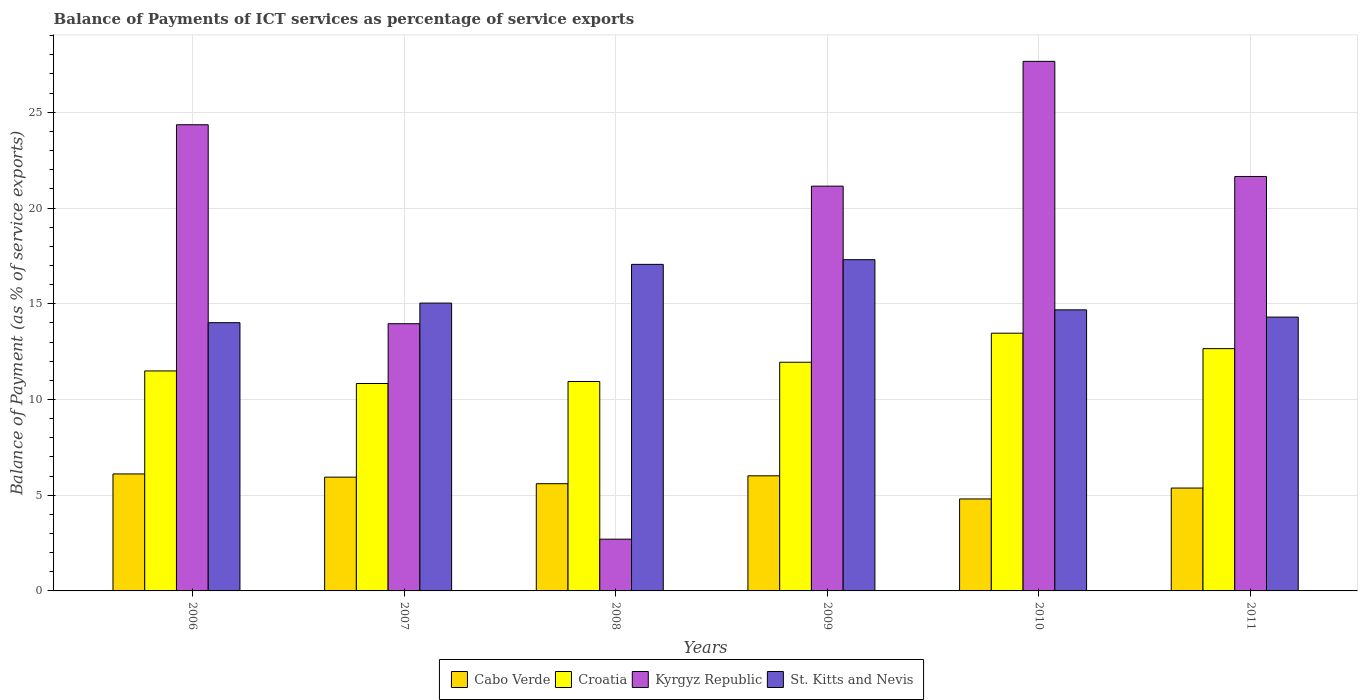How many groups of bars are there?
Ensure brevity in your answer.  6. How many bars are there on the 3rd tick from the left?
Your answer should be compact. 4. In how many cases, is the number of bars for a given year not equal to the number of legend labels?
Offer a very short reply. 0. What is the balance of payments of ICT services in St. Kitts and Nevis in 2006?
Offer a terse response. 14.01. Across all years, what is the maximum balance of payments of ICT services in Kyrgyz Republic?
Keep it short and to the point. 27.66. Across all years, what is the minimum balance of payments of ICT services in Croatia?
Your answer should be compact. 10.83. What is the total balance of payments of ICT services in Cabo Verde in the graph?
Your answer should be very brief. 33.84. What is the difference between the balance of payments of ICT services in Kyrgyz Republic in 2008 and that in 2009?
Provide a succinct answer. -18.44. What is the difference between the balance of payments of ICT services in St. Kitts and Nevis in 2007 and the balance of payments of ICT services in Kyrgyz Republic in 2009?
Provide a succinct answer. -6.11. What is the average balance of payments of ICT services in Cabo Verde per year?
Provide a short and direct response. 5.64. In the year 2010, what is the difference between the balance of payments of ICT services in St. Kitts and Nevis and balance of payments of ICT services in Cabo Verde?
Keep it short and to the point. 9.88. In how many years, is the balance of payments of ICT services in Croatia greater than 9 %?
Your answer should be compact. 6. What is the ratio of the balance of payments of ICT services in Kyrgyz Republic in 2008 to that in 2010?
Offer a very short reply. 0.1. Is the difference between the balance of payments of ICT services in St. Kitts and Nevis in 2006 and 2009 greater than the difference between the balance of payments of ICT services in Cabo Verde in 2006 and 2009?
Give a very brief answer. No. What is the difference between the highest and the second highest balance of payments of ICT services in Croatia?
Ensure brevity in your answer.  0.81. What is the difference between the highest and the lowest balance of payments of ICT services in Cabo Verde?
Provide a short and direct response. 1.31. In how many years, is the balance of payments of ICT services in Croatia greater than the average balance of payments of ICT services in Croatia taken over all years?
Make the answer very short. 3. Is it the case that in every year, the sum of the balance of payments of ICT services in Cabo Verde and balance of payments of ICT services in St. Kitts and Nevis is greater than the sum of balance of payments of ICT services in Croatia and balance of payments of ICT services in Kyrgyz Republic?
Your answer should be very brief. Yes. What does the 4th bar from the left in 2009 represents?
Your response must be concise. St. Kitts and Nevis. What does the 1st bar from the right in 2008 represents?
Your response must be concise. St. Kitts and Nevis. How many bars are there?
Your answer should be compact. 24. What is the difference between two consecutive major ticks on the Y-axis?
Keep it short and to the point. 5. Are the values on the major ticks of Y-axis written in scientific E-notation?
Ensure brevity in your answer.  No. Does the graph contain grids?
Ensure brevity in your answer.  Yes. Where does the legend appear in the graph?
Provide a short and direct response. Bottom center. What is the title of the graph?
Your response must be concise. Balance of Payments of ICT services as percentage of service exports. What is the label or title of the X-axis?
Your response must be concise. Years. What is the label or title of the Y-axis?
Ensure brevity in your answer.  Balance of Payment (as % of service exports). What is the Balance of Payment (as % of service exports) in Cabo Verde in 2006?
Your response must be concise. 6.11. What is the Balance of Payment (as % of service exports) of Croatia in 2006?
Keep it short and to the point. 11.49. What is the Balance of Payment (as % of service exports) in Kyrgyz Republic in 2006?
Keep it short and to the point. 24.35. What is the Balance of Payment (as % of service exports) in St. Kitts and Nevis in 2006?
Your response must be concise. 14.01. What is the Balance of Payment (as % of service exports) in Cabo Verde in 2007?
Provide a succinct answer. 5.94. What is the Balance of Payment (as % of service exports) of Croatia in 2007?
Provide a short and direct response. 10.83. What is the Balance of Payment (as % of service exports) in Kyrgyz Republic in 2007?
Offer a very short reply. 13.96. What is the Balance of Payment (as % of service exports) of St. Kitts and Nevis in 2007?
Provide a short and direct response. 15.03. What is the Balance of Payment (as % of service exports) in Cabo Verde in 2008?
Offer a very short reply. 5.6. What is the Balance of Payment (as % of service exports) of Croatia in 2008?
Offer a very short reply. 10.94. What is the Balance of Payment (as % of service exports) in Kyrgyz Republic in 2008?
Your answer should be very brief. 2.7. What is the Balance of Payment (as % of service exports) in St. Kitts and Nevis in 2008?
Give a very brief answer. 17.06. What is the Balance of Payment (as % of service exports) in Cabo Verde in 2009?
Make the answer very short. 6.01. What is the Balance of Payment (as % of service exports) of Croatia in 2009?
Make the answer very short. 11.94. What is the Balance of Payment (as % of service exports) of Kyrgyz Republic in 2009?
Give a very brief answer. 21.14. What is the Balance of Payment (as % of service exports) of St. Kitts and Nevis in 2009?
Offer a terse response. 17.3. What is the Balance of Payment (as % of service exports) in Cabo Verde in 2010?
Ensure brevity in your answer.  4.8. What is the Balance of Payment (as % of service exports) of Croatia in 2010?
Keep it short and to the point. 13.46. What is the Balance of Payment (as % of service exports) in Kyrgyz Republic in 2010?
Provide a succinct answer. 27.66. What is the Balance of Payment (as % of service exports) of St. Kitts and Nevis in 2010?
Provide a succinct answer. 14.68. What is the Balance of Payment (as % of service exports) of Cabo Verde in 2011?
Ensure brevity in your answer.  5.37. What is the Balance of Payment (as % of service exports) in Croatia in 2011?
Make the answer very short. 12.66. What is the Balance of Payment (as % of service exports) in Kyrgyz Republic in 2011?
Provide a succinct answer. 21.65. What is the Balance of Payment (as % of service exports) of St. Kitts and Nevis in 2011?
Ensure brevity in your answer.  14.3. Across all years, what is the maximum Balance of Payment (as % of service exports) in Cabo Verde?
Your response must be concise. 6.11. Across all years, what is the maximum Balance of Payment (as % of service exports) in Croatia?
Your response must be concise. 13.46. Across all years, what is the maximum Balance of Payment (as % of service exports) in Kyrgyz Republic?
Make the answer very short. 27.66. Across all years, what is the maximum Balance of Payment (as % of service exports) in St. Kitts and Nevis?
Provide a succinct answer. 17.3. Across all years, what is the minimum Balance of Payment (as % of service exports) in Cabo Verde?
Make the answer very short. 4.8. Across all years, what is the minimum Balance of Payment (as % of service exports) of Croatia?
Keep it short and to the point. 10.83. Across all years, what is the minimum Balance of Payment (as % of service exports) of Kyrgyz Republic?
Keep it short and to the point. 2.7. Across all years, what is the minimum Balance of Payment (as % of service exports) of St. Kitts and Nevis?
Give a very brief answer. 14.01. What is the total Balance of Payment (as % of service exports) of Cabo Verde in the graph?
Your answer should be very brief. 33.84. What is the total Balance of Payment (as % of service exports) of Croatia in the graph?
Keep it short and to the point. 71.32. What is the total Balance of Payment (as % of service exports) in Kyrgyz Republic in the graph?
Keep it short and to the point. 111.46. What is the total Balance of Payment (as % of service exports) in St. Kitts and Nevis in the graph?
Ensure brevity in your answer.  92.39. What is the difference between the Balance of Payment (as % of service exports) of Cabo Verde in 2006 and that in 2007?
Provide a short and direct response. 0.17. What is the difference between the Balance of Payment (as % of service exports) of Croatia in 2006 and that in 2007?
Provide a short and direct response. 0.66. What is the difference between the Balance of Payment (as % of service exports) in Kyrgyz Republic in 2006 and that in 2007?
Give a very brief answer. 10.39. What is the difference between the Balance of Payment (as % of service exports) in St. Kitts and Nevis in 2006 and that in 2007?
Offer a very short reply. -1.02. What is the difference between the Balance of Payment (as % of service exports) of Cabo Verde in 2006 and that in 2008?
Your answer should be very brief. 0.51. What is the difference between the Balance of Payment (as % of service exports) of Croatia in 2006 and that in 2008?
Offer a terse response. 0.55. What is the difference between the Balance of Payment (as % of service exports) of Kyrgyz Republic in 2006 and that in 2008?
Offer a very short reply. 21.65. What is the difference between the Balance of Payment (as % of service exports) of St. Kitts and Nevis in 2006 and that in 2008?
Provide a succinct answer. -3.05. What is the difference between the Balance of Payment (as % of service exports) of Cabo Verde in 2006 and that in 2009?
Provide a short and direct response. 0.1. What is the difference between the Balance of Payment (as % of service exports) in Croatia in 2006 and that in 2009?
Ensure brevity in your answer.  -0.45. What is the difference between the Balance of Payment (as % of service exports) in Kyrgyz Republic in 2006 and that in 2009?
Keep it short and to the point. 3.21. What is the difference between the Balance of Payment (as % of service exports) of St. Kitts and Nevis in 2006 and that in 2009?
Your answer should be compact. -3.29. What is the difference between the Balance of Payment (as % of service exports) of Cabo Verde in 2006 and that in 2010?
Offer a very short reply. 1.31. What is the difference between the Balance of Payment (as % of service exports) of Croatia in 2006 and that in 2010?
Make the answer very short. -1.97. What is the difference between the Balance of Payment (as % of service exports) of Kyrgyz Republic in 2006 and that in 2010?
Your answer should be compact. -3.31. What is the difference between the Balance of Payment (as % of service exports) of St. Kitts and Nevis in 2006 and that in 2010?
Your response must be concise. -0.67. What is the difference between the Balance of Payment (as % of service exports) in Cabo Verde in 2006 and that in 2011?
Your answer should be very brief. 0.74. What is the difference between the Balance of Payment (as % of service exports) in Croatia in 2006 and that in 2011?
Your answer should be very brief. -1.16. What is the difference between the Balance of Payment (as % of service exports) of Kyrgyz Republic in 2006 and that in 2011?
Provide a short and direct response. 2.7. What is the difference between the Balance of Payment (as % of service exports) of St. Kitts and Nevis in 2006 and that in 2011?
Ensure brevity in your answer.  -0.29. What is the difference between the Balance of Payment (as % of service exports) in Cabo Verde in 2007 and that in 2008?
Offer a terse response. 0.34. What is the difference between the Balance of Payment (as % of service exports) in Croatia in 2007 and that in 2008?
Give a very brief answer. -0.1. What is the difference between the Balance of Payment (as % of service exports) of Kyrgyz Republic in 2007 and that in 2008?
Offer a very short reply. 11.25. What is the difference between the Balance of Payment (as % of service exports) in St. Kitts and Nevis in 2007 and that in 2008?
Your answer should be compact. -2.02. What is the difference between the Balance of Payment (as % of service exports) of Cabo Verde in 2007 and that in 2009?
Your response must be concise. -0.07. What is the difference between the Balance of Payment (as % of service exports) in Croatia in 2007 and that in 2009?
Provide a succinct answer. -1.11. What is the difference between the Balance of Payment (as % of service exports) of Kyrgyz Republic in 2007 and that in 2009?
Make the answer very short. -7.19. What is the difference between the Balance of Payment (as % of service exports) in St. Kitts and Nevis in 2007 and that in 2009?
Keep it short and to the point. -2.27. What is the difference between the Balance of Payment (as % of service exports) in Cabo Verde in 2007 and that in 2010?
Offer a terse response. 1.14. What is the difference between the Balance of Payment (as % of service exports) of Croatia in 2007 and that in 2010?
Keep it short and to the point. -2.63. What is the difference between the Balance of Payment (as % of service exports) in Kyrgyz Republic in 2007 and that in 2010?
Give a very brief answer. -13.7. What is the difference between the Balance of Payment (as % of service exports) in St. Kitts and Nevis in 2007 and that in 2010?
Your answer should be compact. 0.35. What is the difference between the Balance of Payment (as % of service exports) in Cabo Verde in 2007 and that in 2011?
Your response must be concise. 0.57. What is the difference between the Balance of Payment (as % of service exports) in Croatia in 2007 and that in 2011?
Your response must be concise. -1.82. What is the difference between the Balance of Payment (as % of service exports) in Kyrgyz Republic in 2007 and that in 2011?
Offer a terse response. -7.69. What is the difference between the Balance of Payment (as % of service exports) of St. Kitts and Nevis in 2007 and that in 2011?
Ensure brevity in your answer.  0.73. What is the difference between the Balance of Payment (as % of service exports) of Cabo Verde in 2008 and that in 2009?
Provide a succinct answer. -0.41. What is the difference between the Balance of Payment (as % of service exports) in Croatia in 2008 and that in 2009?
Keep it short and to the point. -1.01. What is the difference between the Balance of Payment (as % of service exports) of Kyrgyz Republic in 2008 and that in 2009?
Provide a short and direct response. -18.44. What is the difference between the Balance of Payment (as % of service exports) of St. Kitts and Nevis in 2008 and that in 2009?
Offer a terse response. -0.24. What is the difference between the Balance of Payment (as % of service exports) in Cabo Verde in 2008 and that in 2010?
Provide a succinct answer. 0.8. What is the difference between the Balance of Payment (as % of service exports) of Croatia in 2008 and that in 2010?
Your answer should be compact. -2.52. What is the difference between the Balance of Payment (as % of service exports) in Kyrgyz Republic in 2008 and that in 2010?
Your answer should be compact. -24.96. What is the difference between the Balance of Payment (as % of service exports) of St. Kitts and Nevis in 2008 and that in 2010?
Your answer should be compact. 2.38. What is the difference between the Balance of Payment (as % of service exports) of Cabo Verde in 2008 and that in 2011?
Your answer should be compact. 0.23. What is the difference between the Balance of Payment (as % of service exports) of Croatia in 2008 and that in 2011?
Your answer should be compact. -1.72. What is the difference between the Balance of Payment (as % of service exports) in Kyrgyz Republic in 2008 and that in 2011?
Your answer should be compact. -18.94. What is the difference between the Balance of Payment (as % of service exports) in St. Kitts and Nevis in 2008 and that in 2011?
Your response must be concise. 2.75. What is the difference between the Balance of Payment (as % of service exports) in Cabo Verde in 2009 and that in 2010?
Your response must be concise. 1.21. What is the difference between the Balance of Payment (as % of service exports) in Croatia in 2009 and that in 2010?
Provide a succinct answer. -1.52. What is the difference between the Balance of Payment (as % of service exports) in Kyrgyz Republic in 2009 and that in 2010?
Make the answer very short. -6.52. What is the difference between the Balance of Payment (as % of service exports) of St. Kitts and Nevis in 2009 and that in 2010?
Make the answer very short. 2.62. What is the difference between the Balance of Payment (as % of service exports) of Cabo Verde in 2009 and that in 2011?
Make the answer very short. 0.64. What is the difference between the Balance of Payment (as % of service exports) in Croatia in 2009 and that in 2011?
Offer a terse response. -0.71. What is the difference between the Balance of Payment (as % of service exports) of Kyrgyz Republic in 2009 and that in 2011?
Your answer should be compact. -0.5. What is the difference between the Balance of Payment (as % of service exports) in St. Kitts and Nevis in 2009 and that in 2011?
Give a very brief answer. 3. What is the difference between the Balance of Payment (as % of service exports) of Cabo Verde in 2010 and that in 2011?
Offer a terse response. -0.57. What is the difference between the Balance of Payment (as % of service exports) in Croatia in 2010 and that in 2011?
Provide a short and direct response. 0.81. What is the difference between the Balance of Payment (as % of service exports) of Kyrgyz Republic in 2010 and that in 2011?
Offer a terse response. 6.01. What is the difference between the Balance of Payment (as % of service exports) in St. Kitts and Nevis in 2010 and that in 2011?
Your answer should be compact. 0.38. What is the difference between the Balance of Payment (as % of service exports) of Cabo Verde in 2006 and the Balance of Payment (as % of service exports) of Croatia in 2007?
Provide a short and direct response. -4.72. What is the difference between the Balance of Payment (as % of service exports) in Cabo Verde in 2006 and the Balance of Payment (as % of service exports) in Kyrgyz Republic in 2007?
Keep it short and to the point. -7.85. What is the difference between the Balance of Payment (as % of service exports) of Cabo Verde in 2006 and the Balance of Payment (as % of service exports) of St. Kitts and Nevis in 2007?
Give a very brief answer. -8.92. What is the difference between the Balance of Payment (as % of service exports) of Croatia in 2006 and the Balance of Payment (as % of service exports) of Kyrgyz Republic in 2007?
Ensure brevity in your answer.  -2.47. What is the difference between the Balance of Payment (as % of service exports) in Croatia in 2006 and the Balance of Payment (as % of service exports) in St. Kitts and Nevis in 2007?
Your answer should be compact. -3.54. What is the difference between the Balance of Payment (as % of service exports) of Kyrgyz Republic in 2006 and the Balance of Payment (as % of service exports) of St. Kitts and Nevis in 2007?
Your answer should be very brief. 9.31. What is the difference between the Balance of Payment (as % of service exports) of Cabo Verde in 2006 and the Balance of Payment (as % of service exports) of Croatia in 2008?
Your answer should be compact. -4.83. What is the difference between the Balance of Payment (as % of service exports) of Cabo Verde in 2006 and the Balance of Payment (as % of service exports) of Kyrgyz Republic in 2008?
Provide a succinct answer. 3.41. What is the difference between the Balance of Payment (as % of service exports) of Cabo Verde in 2006 and the Balance of Payment (as % of service exports) of St. Kitts and Nevis in 2008?
Your answer should be very brief. -10.95. What is the difference between the Balance of Payment (as % of service exports) of Croatia in 2006 and the Balance of Payment (as % of service exports) of Kyrgyz Republic in 2008?
Give a very brief answer. 8.79. What is the difference between the Balance of Payment (as % of service exports) in Croatia in 2006 and the Balance of Payment (as % of service exports) in St. Kitts and Nevis in 2008?
Keep it short and to the point. -5.57. What is the difference between the Balance of Payment (as % of service exports) in Kyrgyz Republic in 2006 and the Balance of Payment (as % of service exports) in St. Kitts and Nevis in 2008?
Your answer should be very brief. 7.29. What is the difference between the Balance of Payment (as % of service exports) of Cabo Verde in 2006 and the Balance of Payment (as % of service exports) of Croatia in 2009?
Provide a succinct answer. -5.83. What is the difference between the Balance of Payment (as % of service exports) in Cabo Verde in 2006 and the Balance of Payment (as % of service exports) in Kyrgyz Republic in 2009?
Your answer should be very brief. -15.03. What is the difference between the Balance of Payment (as % of service exports) in Cabo Verde in 2006 and the Balance of Payment (as % of service exports) in St. Kitts and Nevis in 2009?
Offer a very short reply. -11.19. What is the difference between the Balance of Payment (as % of service exports) in Croatia in 2006 and the Balance of Payment (as % of service exports) in Kyrgyz Republic in 2009?
Give a very brief answer. -9.65. What is the difference between the Balance of Payment (as % of service exports) of Croatia in 2006 and the Balance of Payment (as % of service exports) of St. Kitts and Nevis in 2009?
Offer a very short reply. -5.81. What is the difference between the Balance of Payment (as % of service exports) in Kyrgyz Republic in 2006 and the Balance of Payment (as % of service exports) in St. Kitts and Nevis in 2009?
Ensure brevity in your answer.  7.05. What is the difference between the Balance of Payment (as % of service exports) of Cabo Verde in 2006 and the Balance of Payment (as % of service exports) of Croatia in 2010?
Your answer should be compact. -7.35. What is the difference between the Balance of Payment (as % of service exports) in Cabo Verde in 2006 and the Balance of Payment (as % of service exports) in Kyrgyz Republic in 2010?
Offer a very short reply. -21.55. What is the difference between the Balance of Payment (as % of service exports) of Cabo Verde in 2006 and the Balance of Payment (as % of service exports) of St. Kitts and Nevis in 2010?
Ensure brevity in your answer.  -8.57. What is the difference between the Balance of Payment (as % of service exports) in Croatia in 2006 and the Balance of Payment (as % of service exports) in Kyrgyz Republic in 2010?
Make the answer very short. -16.17. What is the difference between the Balance of Payment (as % of service exports) of Croatia in 2006 and the Balance of Payment (as % of service exports) of St. Kitts and Nevis in 2010?
Give a very brief answer. -3.19. What is the difference between the Balance of Payment (as % of service exports) in Kyrgyz Republic in 2006 and the Balance of Payment (as % of service exports) in St. Kitts and Nevis in 2010?
Keep it short and to the point. 9.67. What is the difference between the Balance of Payment (as % of service exports) in Cabo Verde in 2006 and the Balance of Payment (as % of service exports) in Croatia in 2011?
Ensure brevity in your answer.  -6.54. What is the difference between the Balance of Payment (as % of service exports) of Cabo Verde in 2006 and the Balance of Payment (as % of service exports) of Kyrgyz Republic in 2011?
Make the answer very short. -15.54. What is the difference between the Balance of Payment (as % of service exports) in Cabo Verde in 2006 and the Balance of Payment (as % of service exports) in St. Kitts and Nevis in 2011?
Your answer should be compact. -8.19. What is the difference between the Balance of Payment (as % of service exports) in Croatia in 2006 and the Balance of Payment (as % of service exports) in Kyrgyz Republic in 2011?
Make the answer very short. -10.16. What is the difference between the Balance of Payment (as % of service exports) in Croatia in 2006 and the Balance of Payment (as % of service exports) in St. Kitts and Nevis in 2011?
Your response must be concise. -2.81. What is the difference between the Balance of Payment (as % of service exports) in Kyrgyz Republic in 2006 and the Balance of Payment (as % of service exports) in St. Kitts and Nevis in 2011?
Your response must be concise. 10.05. What is the difference between the Balance of Payment (as % of service exports) in Cabo Verde in 2007 and the Balance of Payment (as % of service exports) in Croatia in 2008?
Keep it short and to the point. -5. What is the difference between the Balance of Payment (as % of service exports) of Cabo Verde in 2007 and the Balance of Payment (as % of service exports) of Kyrgyz Republic in 2008?
Keep it short and to the point. 3.24. What is the difference between the Balance of Payment (as % of service exports) of Cabo Verde in 2007 and the Balance of Payment (as % of service exports) of St. Kitts and Nevis in 2008?
Your response must be concise. -11.11. What is the difference between the Balance of Payment (as % of service exports) in Croatia in 2007 and the Balance of Payment (as % of service exports) in Kyrgyz Republic in 2008?
Offer a very short reply. 8.13. What is the difference between the Balance of Payment (as % of service exports) in Croatia in 2007 and the Balance of Payment (as % of service exports) in St. Kitts and Nevis in 2008?
Your response must be concise. -6.22. What is the difference between the Balance of Payment (as % of service exports) in Kyrgyz Republic in 2007 and the Balance of Payment (as % of service exports) in St. Kitts and Nevis in 2008?
Give a very brief answer. -3.1. What is the difference between the Balance of Payment (as % of service exports) in Cabo Verde in 2007 and the Balance of Payment (as % of service exports) in Croatia in 2009?
Provide a short and direct response. -6. What is the difference between the Balance of Payment (as % of service exports) in Cabo Verde in 2007 and the Balance of Payment (as % of service exports) in Kyrgyz Republic in 2009?
Provide a succinct answer. -15.2. What is the difference between the Balance of Payment (as % of service exports) of Cabo Verde in 2007 and the Balance of Payment (as % of service exports) of St. Kitts and Nevis in 2009?
Make the answer very short. -11.36. What is the difference between the Balance of Payment (as % of service exports) of Croatia in 2007 and the Balance of Payment (as % of service exports) of Kyrgyz Republic in 2009?
Your answer should be compact. -10.31. What is the difference between the Balance of Payment (as % of service exports) in Croatia in 2007 and the Balance of Payment (as % of service exports) in St. Kitts and Nevis in 2009?
Offer a terse response. -6.47. What is the difference between the Balance of Payment (as % of service exports) in Kyrgyz Republic in 2007 and the Balance of Payment (as % of service exports) in St. Kitts and Nevis in 2009?
Your answer should be compact. -3.34. What is the difference between the Balance of Payment (as % of service exports) of Cabo Verde in 2007 and the Balance of Payment (as % of service exports) of Croatia in 2010?
Your answer should be very brief. -7.52. What is the difference between the Balance of Payment (as % of service exports) in Cabo Verde in 2007 and the Balance of Payment (as % of service exports) in Kyrgyz Republic in 2010?
Make the answer very short. -21.72. What is the difference between the Balance of Payment (as % of service exports) in Cabo Verde in 2007 and the Balance of Payment (as % of service exports) in St. Kitts and Nevis in 2010?
Provide a short and direct response. -8.74. What is the difference between the Balance of Payment (as % of service exports) of Croatia in 2007 and the Balance of Payment (as % of service exports) of Kyrgyz Republic in 2010?
Make the answer very short. -16.83. What is the difference between the Balance of Payment (as % of service exports) of Croatia in 2007 and the Balance of Payment (as % of service exports) of St. Kitts and Nevis in 2010?
Your answer should be very brief. -3.85. What is the difference between the Balance of Payment (as % of service exports) in Kyrgyz Republic in 2007 and the Balance of Payment (as % of service exports) in St. Kitts and Nevis in 2010?
Your answer should be very brief. -0.72. What is the difference between the Balance of Payment (as % of service exports) of Cabo Verde in 2007 and the Balance of Payment (as % of service exports) of Croatia in 2011?
Keep it short and to the point. -6.71. What is the difference between the Balance of Payment (as % of service exports) of Cabo Verde in 2007 and the Balance of Payment (as % of service exports) of Kyrgyz Republic in 2011?
Your response must be concise. -15.7. What is the difference between the Balance of Payment (as % of service exports) in Cabo Verde in 2007 and the Balance of Payment (as % of service exports) in St. Kitts and Nevis in 2011?
Ensure brevity in your answer.  -8.36. What is the difference between the Balance of Payment (as % of service exports) in Croatia in 2007 and the Balance of Payment (as % of service exports) in Kyrgyz Republic in 2011?
Keep it short and to the point. -10.81. What is the difference between the Balance of Payment (as % of service exports) of Croatia in 2007 and the Balance of Payment (as % of service exports) of St. Kitts and Nevis in 2011?
Your answer should be very brief. -3.47. What is the difference between the Balance of Payment (as % of service exports) of Kyrgyz Republic in 2007 and the Balance of Payment (as % of service exports) of St. Kitts and Nevis in 2011?
Give a very brief answer. -0.35. What is the difference between the Balance of Payment (as % of service exports) in Cabo Verde in 2008 and the Balance of Payment (as % of service exports) in Croatia in 2009?
Keep it short and to the point. -6.34. What is the difference between the Balance of Payment (as % of service exports) of Cabo Verde in 2008 and the Balance of Payment (as % of service exports) of Kyrgyz Republic in 2009?
Provide a short and direct response. -15.54. What is the difference between the Balance of Payment (as % of service exports) in Cabo Verde in 2008 and the Balance of Payment (as % of service exports) in St. Kitts and Nevis in 2009?
Give a very brief answer. -11.7. What is the difference between the Balance of Payment (as % of service exports) of Croatia in 2008 and the Balance of Payment (as % of service exports) of Kyrgyz Republic in 2009?
Give a very brief answer. -10.2. What is the difference between the Balance of Payment (as % of service exports) of Croatia in 2008 and the Balance of Payment (as % of service exports) of St. Kitts and Nevis in 2009?
Ensure brevity in your answer.  -6.36. What is the difference between the Balance of Payment (as % of service exports) of Kyrgyz Republic in 2008 and the Balance of Payment (as % of service exports) of St. Kitts and Nevis in 2009?
Keep it short and to the point. -14.6. What is the difference between the Balance of Payment (as % of service exports) of Cabo Verde in 2008 and the Balance of Payment (as % of service exports) of Croatia in 2010?
Provide a short and direct response. -7.86. What is the difference between the Balance of Payment (as % of service exports) in Cabo Verde in 2008 and the Balance of Payment (as % of service exports) in Kyrgyz Republic in 2010?
Your answer should be very brief. -22.06. What is the difference between the Balance of Payment (as % of service exports) of Cabo Verde in 2008 and the Balance of Payment (as % of service exports) of St. Kitts and Nevis in 2010?
Offer a very short reply. -9.08. What is the difference between the Balance of Payment (as % of service exports) of Croatia in 2008 and the Balance of Payment (as % of service exports) of Kyrgyz Republic in 2010?
Provide a succinct answer. -16.72. What is the difference between the Balance of Payment (as % of service exports) in Croatia in 2008 and the Balance of Payment (as % of service exports) in St. Kitts and Nevis in 2010?
Your answer should be compact. -3.74. What is the difference between the Balance of Payment (as % of service exports) in Kyrgyz Republic in 2008 and the Balance of Payment (as % of service exports) in St. Kitts and Nevis in 2010?
Provide a succinct answer. -11.98. What is the difference between the Balance of Payment (as % of service exports) in Cabo Verde in 2008 and the Balance of Payment (as % of service exports) in Croatia in 2011?
Give a very brief answer. -7.05. What is the difference between the Balance of Payment (as % of service exports) of Cabo Verde in 2008 and the Balance of Payment (as % of service exports) of Kyrgyz Republic in 2011?
Offer a very short reply. -16.05. What is the difference between the Balance of Payment (as % of service exports) of Cabo Verde in 2008 and the Balance of Payment (as % of service exports) of St. Kitts and Nevis in 2011?
Offer a very short reply. -8.7. What is the difference between the Balance of Payment (as % of service exports) in Croatia in 2008 and the Balance of Payment (as % of service exports) in Kyrgyz Republic in 2011?
Your response must be concise. -10.71. What is the difference between the Balance of Payment (as % of service exports) in Croatia in 2008 and the Balance of Payment (as % of service exports) in St. Kitts and Nevis in 2011?
Ensure brevity in your answer.  -3.36. What is the difference between the Balance of Payment (as % of service exports) of Kyrgyz Republic in 2008 and the Balance of Payment (as % of service exports) of St. Kitts and Nevis in 2011?
Ensure brevity in your answer.  -11.6. What is the difference between the Balance of Payment (as % of service exports) of Cabo Verde in 2009 and the Balance of Payment (as % of service exports) of Croatia in 2010?
Ensure brevity in your answer.  -7.45. What is the difference between the Balance of Payment (as % of service exports) in Cabo Verde in 2009 and the Balance of Payment (as % of service exports) in Kyrgyz Republic in 2010?
Your answer should be very brief. -21.65. What is the difference between the Balance of Payment (as % of service exports) in Cabo Verde in 2009 and the Balance of Payment (as % of service exports) in St. Kitts and Nevis in 2010?
Offer a terse response. -8.67. What is the difference between the Balance of Payment (as % of service exports) in Croatia in 2009 and the Balance of Payment (as % of service exports) in Kyrgyz Republic in 2010?
Offer a terse response. -15.72. What is the difference between the Balance of Payment (as % of service exports) of Croatia in 2009 and the Balance of Payment (as % of service exports) of St. Kitts and Nevis in 2010?
Offer a terse response. -2.74. What is the difference between the Balance of Payment (as % of service exports) of Kyrgyz Republic in 2009 and the Balance of Payment (as % of service exports) of St. Kitts and Nevis in 2010?
Your answer should be very brief. 6.46. What is the difference between the Balance of Payment (as % of service exports) of Cabo Verde in 2009 and the Balance of Payment (as % of service exports) of Croatia in 2011?
Your answer should be compact. -6.64. What is the difference between the Balance of Payment (as % of service exports) of Cabo Verde in 2009 and the Balance of Payment (as % of service exports) of Kyrgyz Republic in 2011?
Keep it short and to the point. -15.63. What is the difference between the Balance of Payment (as % of service exports) of Cabo Verde in 2009 and the Balance of Payment (as % of service exports) of St. Kitts and Nevis in 2011?
Your answer should be compact. -8.29. What is the difference between the Balance of Payment (as % of service exports) of Croatia in 2009 and the Balance of Payment (as % of service exports) of Kyrgyz Republic in 2011?
Your answer should be compact. -9.7. What is the difference between the Balance of Payment (as % of service exports) in Croatia in 2009 and the Balance of Payment (as % of service exports) in St. Kitts and Nevis in 2011?
Your response must be concise. -2.36. What is the difference between the Balance of Payment (as % of service exports) of Kyrgyz Republic in 2009 and the Balance of Payment (as % of service exports) of St. Kitts and Nevis in 2011?
Provide a short and direct response. 6.84. What is the difference between the Balance of Payment (as % of service exports) of Cabo Verde in 2010 and the Balance of Payment (as % of service exports) of Croatia in 2011?
Make the answer very short. -7.85. What is the difference between the Balance of Payment (as % of service exports) in Cabo Verde in 2010 and the Balance of Payment (as % of service exports) in Kyrgyz Republic in 2011?
Provide a succinct answer. -16.84. What is the difference between the Balance of Payment (as % of service exports) of Cabo Verde in 2010 and the Balance of Payment (as % of service exports) of St. Kitts and Nevis in 2011?
Your answer should be very brief. -9.5. What is the difference between the Balance of Payment (as % of service exports) in Croatia in 2010 and the Balance of Payment (as % of service exports) in Kyrgyz Republic in 2011?
Make the answer very short. -8.19. What is the difference between the Balance of Payment (as % of service exports) in Croatia in 2010 and the Balance of Payment (as % of service exports) in St. Kitts and Nevis in 2011?
Make the answer very short. -0.84. What is the difference between the Balance of Payment (as % of service exports) in Kyrgyz Republic in 2010 and the Balance of Payment (as % of service exports) in St. Kitts and Nevis in 2011?
Your answer should be very brief. 13.36. What is the average Balance of Payment (as % of service exports) in Cabo Verde per year?
Offer a terse response. 5.64. What is the average Balance of Payment (as % of service exports) of Croatia per year?
Give a very brief answer. 11.89. What is the average Balance of Payment (as % of service exports) of Kyrgyz Republic per year?
Provide a succinct answer. 18.58. What is the average Balance of Payment (as % of service exports) in St. Kitts and Nevis per year?
Your answer should be compact. 15.4. In the year 2006, what is the difference between the Balance of Payment (as % of service exports) in Cabo Verde and Balance of Payment (as % of service exports) in Croatia?
Your answer should be compact. -5.38. In the year 2006, what is the difference between the Balance of Payment (as % of service exports) in Cabo Verde and Balance of Payment (as % of service exports) in Kyrgyz Republic?
Provide a succinct answer. -18.24. In the year 2006, what is the difference between the Balance of Payment (as % of service exports) in Cabo Verde and Balance of Payment (as % of service exports) in St. Kitts and Nevis?
Provide a short and direct response. -7.9. In the year 2006, what is the difference between the Balance of Payment (as % of service exports) of Croatia and Balance of Payment (as % of service exports) of Kyrgyz Republic?
Ensure brevity in your answer.  -12.86. In the year 2006, what is the difference between the Balance of Payment (as % of service exports) in Croatia and Balance of Payment (as % of service exports) in St. Kitts and Nevis?
Your answer should be very brief. -2.52. In the year 2006, what is the difference between the Balance of Payment (as % of service exports) in Kyrgyz Republic and Balance of Payment (as % of service exports) in St. Kitts and Nevis?
Provide a short and direct response. 10.34. In the year 2007, what is the difference between the Balance of Payment (as % of service exports) of Cabo Verde and Balance of Payment (as % of service exports) of Croatia?
Ensure brevity in your answer.  -4.89. In the year 2007, what is the difference between the Balance of Payment (as % of service exports) in Cabo Verde and Balance of Payment (as % of service exports) in Kyrgyz Republic?
Your answer should be very brief. -8.01. In the year 2007, what is the difference between the Balance of Payment (as % of service exports) of Cabo Verde and Balance of Payment (as % of service exports) of St. Kitts and Nevis?
Give a very brief answer. -9.09. In the year 2007, what is the difference between the Balance of Payment (as % of service exports) in Croatia and Balance of Payment (as % of service exports) in Kyrgyz Republic?
Your response must be concise. -3.12. In the year 2007, what is the difference between the Balance of Payment (as % of service exports) of Kyrgyz Republic and Balance of Payment (as % of service exports) of St. Kitts and Nevis?
Provide a short and direct response. -1.08. In the year 2008, what is the difference between the Balance of Payment (as % of service exports) in Cabo Verde and Balance of Payment (as % of service exports) in Croatia?
Offer a very short reply. -5.34. In the year 2008, what is the difference between the Balance of Payment (as % of service exports) of Cabo Verde and Balance of Payment (as % of service exports) of Kyrgyz Republic?
Keep it short and to the point. 2.9. In the year 2008, what is the difference between the Balance of Payment (as % of service exports) of Cabo Verde and Balance of Payment (as % of service exports) of St. Kitts and Nevis?
Keep it short and to the point. -11.46. In the year 2008, what is the difference between the Balance of Payment (as % of service exports) in Croatia and Balance of Payment (as % of service exports) in Kyrgyz Republic?
Offer a very short reply. 8.23. In the year 2008, what is the difference between the Balance of Payment (as % of service exports) in Croatia and Balance of Payment (as % of service exports) in St. Kitts and Nevis?
Offer a very short reply. -6.12. In the year 2008, what is the difference between the Balance of Payment (as % of service exports) of Kyrgyz Republic and Balance of Payment (as % of service exports) of St. Kitts and Nevis?
Your answer should be very brief. -14.35. In the year 2009, what is the difference between the Balance of Payment (as % of service exports) in Cabo Verde and Balance of Payment (as % of service exports) in Croatia?
Your answer should be compact. -5.93. In the year 2009, what is the difference between the Balance of Payment (as % of service exports) in Cabo Verde and Balance of Payment (as % of service exports) in Kyrgyz Republic?
Your response must be concise. -15.13. In the year 2009, what is the difference between the Balance of Payment (as % of service exports) in Cabo Verde and Balance of Payment (as % of service exports) in St. Kitts and Nevis?
Offer a terse response. -11.29. In the year 2009, what is the difference between the Balance of Payment (as % of service exports) of Croatia and Balance of Payment (as % of service exports) of Kyrgyz Republic?
Offer a terse response. -9.2. In the year 2009, what is the difference between the Balance of Payment (as % of service exports) in Croatia and Balance of Payment (as % of service exports) in St. Kitts and Nevis?
Offer a very short reply. -5.36. In the year 2009, what is the difference between the Balance of Payment (as % of service exports) of Kyrgyz Republic and Balance of Payment (as % of service exports) of St. Kitts and Nevis?
Your answer should be compact. 3.84. In the year 2010, what is the difference between the Balance of Payment (as % of service exports) in Cabo Verde and Balance of Payment (as % of service exports) in Croatia?
Make the answer very short. -8.66. In the year 2010, what is the difference between the Balance of Payment (as % of service exports) in Cabo Verde and Balance of Payment (as % of service exports) in Kyrgyz Republic?
Offer a very short reply. -22.86. In the year 2010, what is the difference between the Balance of Payment (as % of service exports) in Cabo Verde and Balance of Payment (as % of service exports) in St. Kitts and Nevis?
Provide a succinct answer. -9.88. In the year 2010, what is the difference between the Balance of Payment (as % of service exports) of Croatia and Balance of Payment (as % of service exports) of Kyrgyz Republic?
Give a very brief answer. -14.2. In the year 2010, what is the difference between the Balance of Payment (as % of service exports) of Croatia and Balance of Payment (as % of service exports) of St. Kitts and Nevis?
Keep it short and to the point. -1.22. In the year 2010, what is the difference between the Balance of Payment (as % of service exports) of Kyrgyz Republic and Balance of Payment (as % of service exports) of St. Kitts and Nevis?
Give a very brief answer. 12.98. In the year 2011, what is the difference between the Balance of Payment (as % of service exports) of Cabo Verde and Balance of Payment (as % of service exports) of Croatia?
Your answer should be compact. -7.28. In the year 2011, what is the difference between the Balance of Payment (as % of service exports) in Cabo Verde and Balance of Payment (as % of service exports) in Kyrgyz Republic?
Ensure brevity in your answer.  -16.27. In the year 2011, what is the difference between the Balance of Payment (as % of service exports) in Cabo Verde and Balance of Payment (as % of service exports) in St. Kitts and Nevis?
Offer a terse response. -8.93. In the year 2011, what is the difference between the Balance of Payment (as % of service exports) of Croatia and Balance of Payment (as % of service exports) of Kyrgyz Republic?
Make the answer very short. -8.99. In the year 2011, what is the difference between the Balance of Payment (as % of service exports) of Croatia and Balance of Payment (as % of service exports) of St. Kitts and Nevis?
Your answer should be very brief. -1.65. In the year 2011, what is the difference between the Balance of Payment (as % of service exports) in Kyrgyz Republic and Balance of Payment (as % of service exports) in St. Kitts and Nevis?
Provide a succinct answer. 7.34. What is the ratio of the Balance of Payment (as % of service exports) of Cabo Verde in 2006 to that in 2007?
Provide a succinct answer. 1.03. What is the ratio of the Balance of Payment (as % of service exports) in Croatia in 2006 to that in 2007?
Provide a short and direct response. 1.06. What is the ratio of the Balance of Payment (as % of service exports) in Kyrgyz Republic in 2006 to that in 2007?
Ensure brevity in your answer.  1.74. What is the ratio of the Balance of Payment (as % of service exports) in St. Kitts and Nevis in 2006 to that in 2007?
Your answer should be compact. 0.93. What is the ratio of the Balance of Payment (as % of service exports) in Cabo Verde in 2006 to that in 2008?
Offer a terse response. 1.09. What is the ratio of the Balance of Payment (as % of service exports) in Croatia in 2006 to that in 2008?
Give a very brief answer. 1.05. What is the ratio of the Balance of Payment (as % of service exports) in Kyrgyz Republic in 2006 to that in 2008?
Provide a short and direct response. 9.01. What is the ratio of the Balance of Payment (as % of service exports) of St. Kitts and Nevis in 2006 to that in 2008?
Make the answer very short. 0.82. What is the ratio of the Balance of Payment (as % of service exports) in Cabo Verde in 2006 to that in 2009?
Your response must be concise. 1.02. What is the ratio of the Balance of Payment (as % of service exports) in Croatia in 2006 to that in 2009?
Provide a succinct answer. 0.96. What is the ratio of the Balance of Payment (as % of service exports) of Kyrgyz Republic in 2006 to that in 2009?
Provide a succinct answer. 1.15. What is the ratio of the Balance of Payment (as % of service exports) in St. Kitts and Nevis in 2006 to that in 2009?
Make the answer very short. 0.81. What is the ratio of the Balance of Payment (as % of service exports) of Cabo Verde in 2006 to that in 2010?
Offer a very short reply. 1.27. What is the ratio of the Balance of Payment (as % of service exports) in Croatia in 2006 to that in 2010?
Give a very brief answer. 0.85. What is the ratio of the Balance of Payment (as % of service exports) in Kyrgyz Republic in 2006 to that in 2010?
Your answer should be compact. 0.88. What is the ratio of the Balance of Payment (as % of service exports) in St. Kitts and Nevis in 2006 to that in 2010?
Offer a terse response. 0.95. What is the ratio of the Balance of Payment (as % of service exports) of Cabo Verde in 2006 to that in 2011?
Keep it short and to the point. 1.14. What is the ratio of the Balance of Payment (as % of service exports) of Croatia in 2006 to that in 2011?
Offer a terse response. 0.91. What is the ratio of the Balance of Payment (as % of service exports) of Kyrgyz Republic in 2006 to that in 2011?
Keep it short and to the point. 1.12. What is the ratio of the Balance of Payment (as % of service exports) of St. Kitts and Nevis in 2006 to that in 2011?
Give a very brief answer. 0.98. What is the ratio of the Balance of Payment (as % of service exports) in Cabo Verde in 2007 to that in 2008?
Ensure brevity in your answer.  1.06. What is the ratio of the Balance of Payment (as % of service exports) of Kyrgyz Republic in 2007 to that in 2008?
Offer a terse response. 5.16. What is the ratio of the Balance of Payment (as % of service exports) in St. Kitts and Nevis in 2007 to that in 2008?
Give a very brief answer. 0.88. What is the ratio of the Balance of Payment (as % of service exports) of Cabo Verde in 2007 to that in 2009?
Provide a short and direct response. 0.99. What is the ratio of the Balance of Payment (as % of service exports) in Croatia in 2007 to that in 2009?
Your answer should be very brief. 0.91. What is the ratio of the Balance of Payment (as % of service exports) in Kyrgyz Republic in 2007 to that in 2009?
Give a very brief answer. 0.66. What is the ratio of the Balance of Payment (as % of service exports) in St. Kitts and Nevis in 2007 to that in 2009?
Make the answer very short. 0.87. What is the ratio of the Balance of Payment (as % of service exports) in Cabo Verde in 2007 to that in 2010?
Your answer should be very brief. 1.24. What is the ratio of the Balance of Payment (as % of service exports) in Croatia in 2007 to that in 2010?
Your answer should be compact. 0.8. What is the ratio of the Balance of Payment (as % of service exports) in Kyrgyz Republic in 2007 to that in 2010?
Offer a very short reply. 0.5. What is the ratio of the Balance of Payment (as % of service exports) of St. Kitts and Nevis in 2007 to that in 2010?
Offer a terse response. 1.02. What is the ratio of the Balance of Payment (as % of service exports) of Cabo Verde in 2007 to that in 2011?
Keep it short and to the point. 1.11. What is the ratio of the Balance of Payment (as % of service exports) of Croatia in 2007 to that in 2011?
Offer a very short reply. 0.86. What is the ratio of the Balance of Payment (as % of service exports) in Kyrgyz Republic in 2007 to that in 2011?
Offer a very short reply. 0.64. What is the ratio of the Balance of Payment (as % of service exports) of St. Kitts and Nevis in 2007 to that in 2011?
Give a very brief answer. 1.05. What is the ratio of the Balance of Payment (as % of service exports) of Cabo Verde in 2008 to that in 2009?
Provide a succinct answer. 0.93. What is the ratio of the Balance of Payment (as % of service exports) in Croatia in 2008 to that in 2009?
Your response must be concise. 0.92. What is the ratio of the Balance of Payment (as % of service exports) in Kyrgyz Republic in 2008 to that in 2009?
Offer a terse response. 0.13. What is the ratio of the Balance of Payment (as % of service exports) of St. Kitts and Nevis in 2008 to that in 2009?
Provide a succinct answer. 0.99. What is the ratio of the Balance of Payment (as % of service exports) of Cabo Verde in 2008 to that in 2010?
Give a very brief answer. 1.17. What is the ratio of the Balance of Payment (as % of service exports) in Croatia in 2008 to that in 2010?
Ensure brevity in your answer.  0.81. What is the ratio of the Balance of Payment (as % of service exports) in Kyrgyz Republic in 2008 to that in 2010?
Your response must be concise. 0.1. What is the ratio of the Balance of Payment (as % of service exports) in St. Kitts and Nevis in 2008 to that in 2010?
Provide a succinct answer. 1.16. What is the ratio of the Balance of Payment (as % of service exports) in Cabo Verde in 2008 to that in 2011?
Your answer should be compact. 1.04. What is the ratio of the Balance of Payment (as % of service exports) in Croatia in 2008 to that in 2011?
Provide a succinct answer. 0.86. What is the ratio of the Balance of Payment (as % of service exports) in Kyrgyz Republic in 2008 to that in 2011?
Your response must be concise. 0.12. What is the ratio of the Balance of Payment (as % of service exports) in St. Kitts and Nevis in 2008 to that in 2011?
Give a very brief answer. 1.19. What is the ratio of the Balance of Payment (as % of service exports) in Cabo Verde in 2009 to that in 2010?
Provide a short and direct response. 1.25. What is the ratio of the Balance of Payment (as % of service exports) in Croatia in 2009 to that in 2010?
Provide a succinct answer. 0.89. What is the ratio of the Balance of Payment (as % of service exports) in Kyrgyz Republic in 2009 to that in 2010?
Offer a very short reply. 0.76. What is the ratio of the Balance of Payment (as % of service exports) of St. Kitts and Nevis in 2009 to that in 2010?
Your response must be concise. 1.18. What is the ratio of the Balance of Payment (as % of service exports) in Cabo Verde in 2009 to that in 2011?
Your answer should be very brief. 1.12. What is the ratio of the Balance of Payment (as % of service exports) in Croatia in 2009 to that in 2011?
Make the answer very short. 0.94. What is the ratio of the Balance of Payment (as % of service exports) of Kyrgyz Republic in 2009 to that in 2011?
Offer a very short reply. 0.98. What is the ratio of the Balance of Payment (as % of service exports) of St. Kitts and Nevis in 2009 to that in 2011?
Your response must be concise. 1.21. What is the ratio of the Balance of Payment (as % of service exports) of Cabo Verde in 2010 to that in 2011?
Your response must be concise. 0.89. What is the ratio of the Balance of Payment (as % of service exports) in Croatia in 2010 to that in 2011?
Your answer should be compact. 1.06. What is the ratio of the Balance of Payment (as % of service exports) of Kyrgyz Republic in 2010 to that in 2011?
Keep it short and to the point. 1.28. What is the ratio of the Balance of Payment (as % of service exports) in St. Kitts and Nevis in 2010 to that in 2011?
Keep it short and to the point. 1.03. What is the difference between the highest and the second highest Balance of Payment (as % of service exports) in Cabo Verde?
Your answer should be compact. 0.1. What is the difference between the highest and the second highest Balance of Payment (as % of service exports) in Croatia?
Ensure brevity in your answer.  0.81. What is the difference between the highest and the second highest Balance of Payment (as % of service exports) in Kyrgyz Republic?
Give a very brief answer. 3.31. What is the difference between the highest and the second highest Balance of Payment (as % of service exports) of St. Kitts and Nevis?
Your response must be concise. 0.24. What is the difference between the highest and the lowest Balance of Payment (as % of service exports) of Cabo Verde?
Provide a short and direct response. 1.31. What is the difference between the highest and the lowest Balance of Payment (as % of service exports) of Croatia?
Provide a short and direct response. 2.63. What is the difference between the highest and the lowest Balance of Payment (as % of service exports) of Kyrgyz Republic?
Offer a very short reply. 24.96. What is the difference between the highest and the lowest Balance of Payment (as % of service exports) in St. Kitts and Nevis?
Your response must be concise. 3.29. 